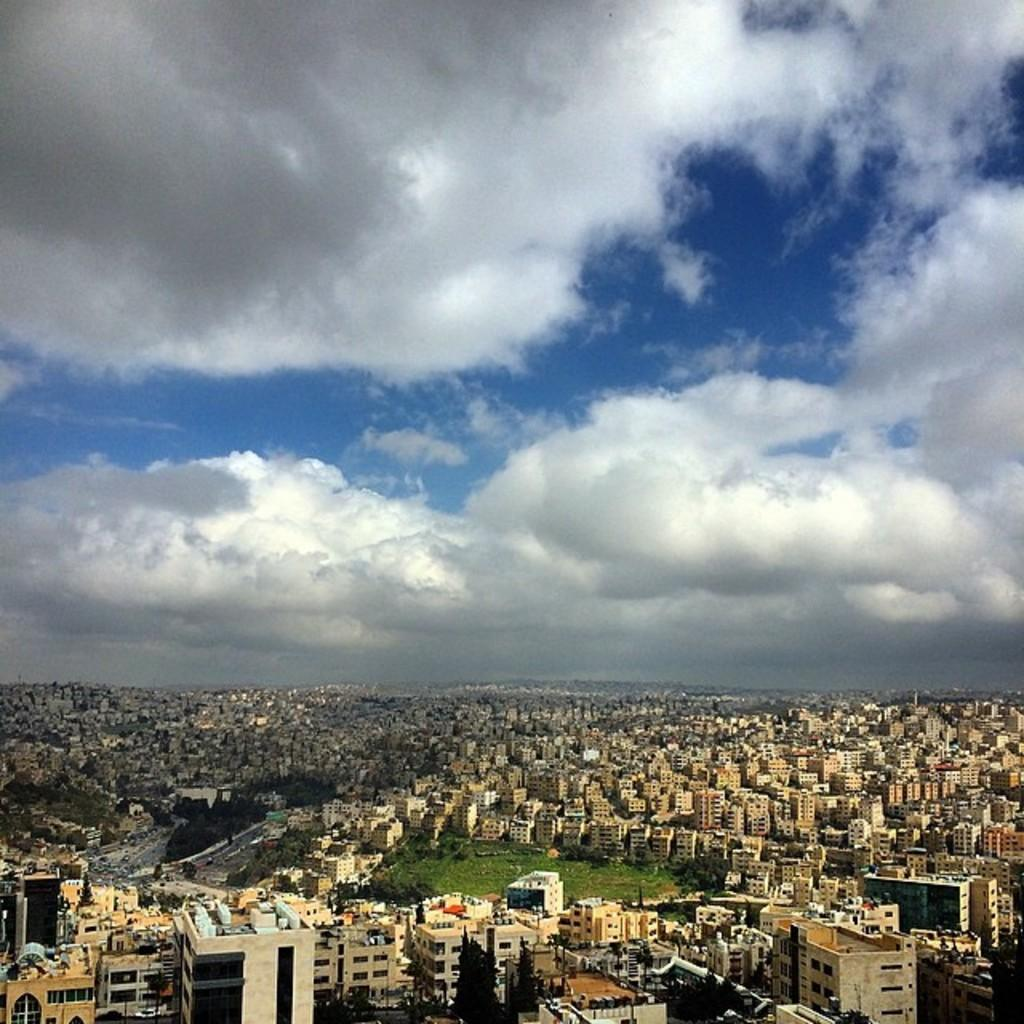What type of structures can be seen in the image? There are many buildings in the image. What else can be seen besides the buildings? There are poles and trees visible in the image. Where are the trees located in the image? The trees are at the bottom side of the image. What is visible at the top side of the image? The sky is visible at the top side of the image. What is the reason for the heat in the image? There is no mention of heat in the image, so it is not possible to determine the reason for any heat. 